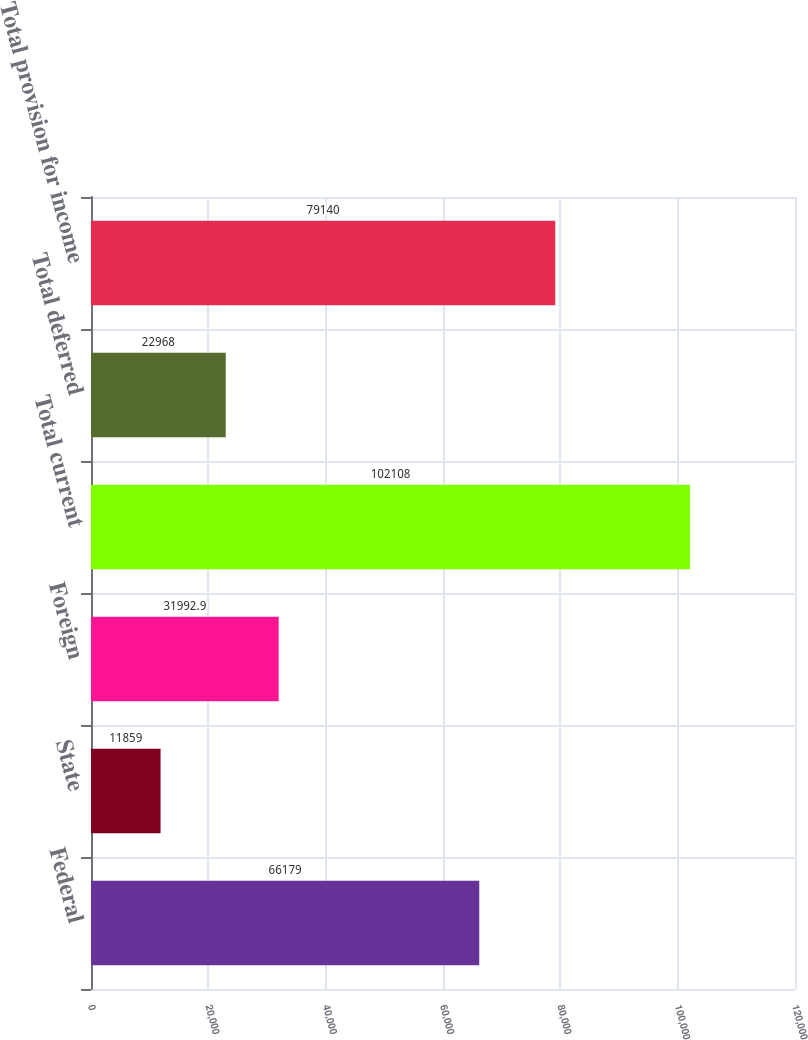<chart> <loc_0><loc_0><loc_500><loc_500><bar_chart><fcel>Federal<fcel>State<fcel>Foreign<fcel>Total current<fcel>Total deferred<fcel>Total provision for income<nl><fcel>66179<fcel>11859<fcel>31992.9<fcel>102108<fcel>22968<fcel>79140<nl></chart> 